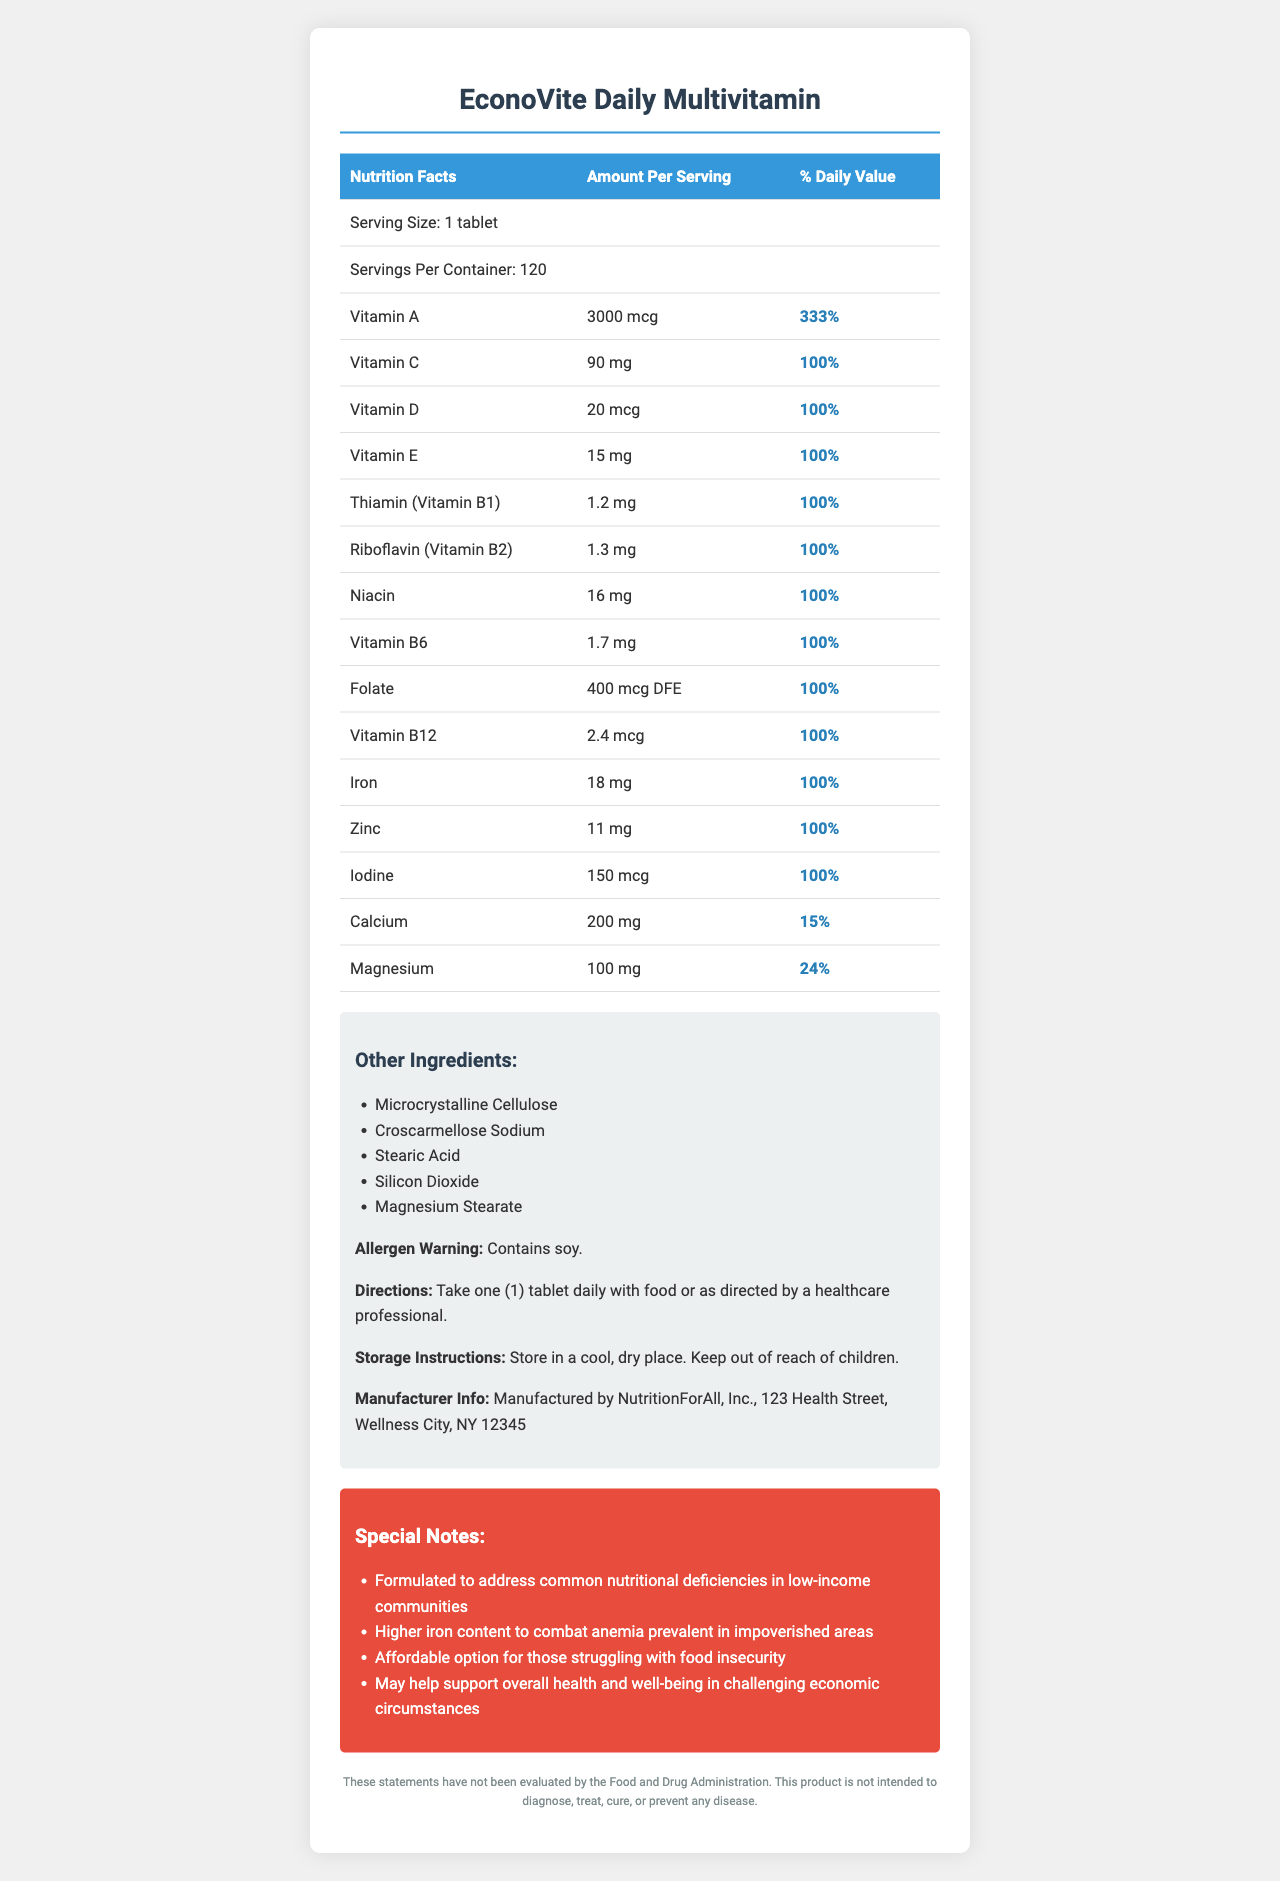what is the serving size for EconoVite Daily Multivitamin? The document shows "Serving Size: 1 tablet" in the Nutrition Facts section.
Answer: 1 tablet how many servings are in one container of EconoVite Daily Multivitamin? The document states "Servings Per Container: 120."
Answer: 120 how much Vitamin C is in each serving? Under the Nutrition Facts, it lists Vitamin C as having 90 mg per serving.
Answer: 90 mg what is the daily value percentage of Iron in this supplement? The Iron amount listed in the Nutrition Facts shows a daily value of 100%.
Answer: 100% what nutrient has the highest daily value percentage in this supplement? Vitamin A has a daily value of 333%, which is the highest among all listed nutrients.
Answer: Vitamin A which vitamin is present in the smallest amount? A. Vitamin D B. Vitamin B12 C. Vitamin B6 D. Vitamin E Vitamin B12 is present at 2.4 mcg, which is the smallest amount listed.
Answer: B which of the following is not an ingredient in EconoVite? 1. Microcrystalline Cellulose 2. Stearic Acid 3. Gelatin 4. Silicon Dioxide The Other Ingredients section lists Microcrystalline Cellulose, Stearic Acid, and Silicon Dioxide, but not Gelatin.
Answer: 3 does the document indicate if this supplement is intended to diagnose, treat, cure, or prevent any disease? The disclaimer states that the product is not intended to diagnose, treat, cure, or prevent any disease.
Answer: No is there an allergen warning associated with this product? The document states "Contains soy" under the allergen warning.
Answer: Yes summarize the main features of the EconoVite Daily Multivitamin document. The document is structured to provide essential information about the multivitamin, including the purpose and target audience of the product. It covers nutritional content, usage instructions, and special considerations for users.
Answer: The EconoVite Daily Multivitamin document provides the supplement's nutritional information, serving sizes, number of servings per container, detailed supplement facts with amounts and daily values, other ingredients, allergen warning, directions for use, storage instructions, manufacturer info, disclaimer, and special notes highlighting its formulation for addressing deficiencies common in low-income communities. what effects of poverty on mental health might this multivitamin address? The document does not provide specific information on mental health. It mentions general health and well-being support but does not detail mental health impacts.
Answer: Not enough information 